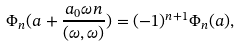Convert formula to latex. <formula><loc_0><loc_0><loc_500><loc_500>\Phi _ { n } ( a + \frac { a _ { 0 } \omega n } { ( \omega , \omega ) } ) = ( - 1 ) ^ { n + 1 } \Phi _ { n } ( a ) ,</formula> 